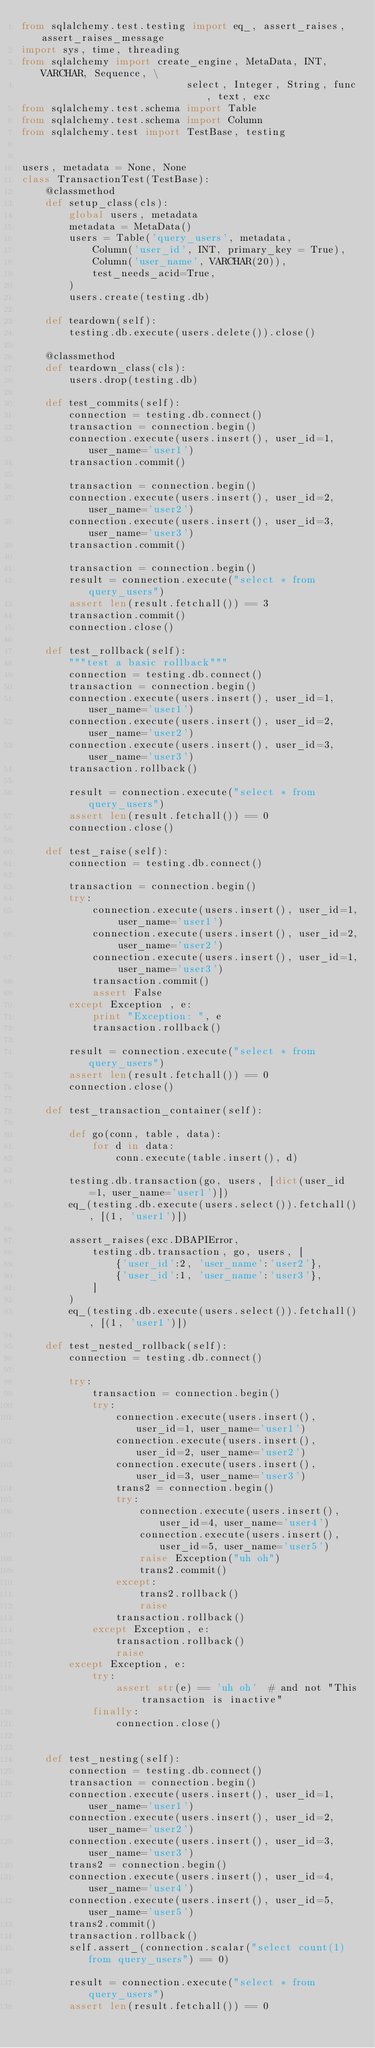Convert code to text. <code><loc_0><loc_0><loc_500><loc_500><_Python_>from sqlalchemy.test.testing import eq_, assert_raises, assert_raises_message
import sys, time, threading
from sqlalchemy import create_engine, MetaData, INT, VARCHAR, Sequence, \
                            select, Integer, String, func, text, exc
from sqlalchemy.test.schema import Table
from sqlalchemy.test.schema import Column
from sqlalchemy.test import TestBase, testing


users, metadata = None, None
class TransactionTest(TestBase):
    @classmethod
    def setup_class(cls):
        global users, metadata
        metadata = MetaData()
        users = Table('query_users', metadata,
            Column('user_id', INT, primary_key = True),
            Column('user_name', VARCHAR(20)),
            test_needs_acid=True,
        )
        users.create(testing.db)

    def teardown(self):
        testing.db.execute(users.delete()).close()

    @classmethod
    def teardown_class(cls):
        users.drop(testing.db)

    def test_commits(self):
        connection = testing.db.connect()
        transaction = connection.begin()
        connection.execute(users.insert(), user_id=1, user_name='user1')
        transaction.commit()

        transaction = connection.begin()
        connection.execute(users.insert(), user_id=2, user_name='user2')
        connection.execute(users.insert(), user_id=3, user_name='user3')
        transaction.commit()

        transaction = connection.begin()
        result = connection.execute("select * from query_users")
        assert len(result.fetchall()) == 3
        transaction.commit()
        connection.close()

    def test_rollback(self):
        """test a basic rollback"""
        connection = testing.db.connect()
        transaction = connection.begin()
        connection.execute(users.insert(), user_id=1, user_name='user1')
        connection.execute(users.insert(), user_id=2, user_name='user2')
        connection.execute(users.insert(), user_id=3, user_name='user3')
        transaction.rollback()

        result = connection.execute("select * from query_users")
        assert len(result.fetchall()) == 0
        connection.close()

    def test_raise(self):
        connection = testing.db.connect()

        transaction = connection.begin()
        try:
            connection.execute(users.insert(), user_id=1, user_name='user1')
            connection.execute(users.insert(), user_id=2, user_name='user2')
            connection.execute(users.insert(), user_id=1, user_name='user3')
            transaction.commit()
            assert False
        except Exception , e:
            print "Exception: ", e
            transaction.rollback()

        result = connection.execute("select * from query_users")
        assert len(result.fetchall()) == 0
        connection.close()
    
    def test_transaction_container(self):
        
        def go(conn, table, data):
            for d in data:
                conn.execute(table.insert(), d)
            
        testing.db.transaction(go, users, [dict(user_id=1, user_name='user1')])
        eq_(testing.db.execute(users.select()).fetchall(), [(1, 'user1')])
        
        assert_raises(exc.DBAPIError, 
            testing.db.transaction, go, users, [
                {'user_id':2, 'user_name':'user2'},
                {'user_id':1, 'user_name':'user3'},
            ]
        )
        eq_(testing.db.execute(users.select()).fetchall(), [(1, 'user1')])
        
    def test_nested_rollback(self):
        connection = testing.db.connect()

        try:
            transaction = connection.begin()
            try:
                connection.execute(users.insert(), user_id=1, user_name='user1')
                connection.execute(users.insert(), user_id=2, user_name='user2')
                connection.execute(users.insert(), user_id=3, user_name='user3')
                trans2 = connection.begin()
                try:
                    connection.execute(users.insert(), user_id=4, user_name='user4')
                    connection.execute(users.insert(), user_id=5, user_name='user5')
                    raise Exception("uh oh")
                    trans2.commit()
                except:
                    trans2.rollback()
                    raise
                transaction.rollback()
            except Exception, e:
                transaction.rollback()
                raise
        except Exception, e:
            try:
                assert str(e) == 'uh oh'  # and not "This transaction is inactive"
            finally:
                connection.close()


    def test_nesting(self):
        connection = testing.db.connect()
        transaction = connection.begin()
        connection.execute(users.insert(), user_id=1, user_name='user1')
        connection.execute(users.insert(), user_id=2, user_name='user2')
        connection.execute(users.insert(), user_id=3, user_name='user3')
        trans2 = connection.begin()
        connection.execute(users.insert(), user_id=4, user_name='user4')
        connection.execute(users.insert(), user_id=5, user_name='user5')
        trans2.commit()
        transaction.rollback()
        self.assert_(connection.scalar("select count(1) from query_users") == 0)

        result = connection.execute("select * from query_users")
        assert len(result.fetchall()) == 0</code> 